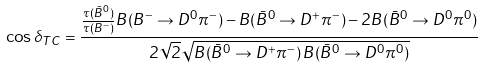Convert formula to latex. <formula><loc_0><loc_0><loc_500><loc_500>\cos \delta _ { T C } = \frac { \frac { \tau ( \bar { B } ^ { 0 } ) } { \tau ( B ^ { - } ) } B ( B ^ { - } \to D ^ { 0 } \pi ^ { - } ) - B ( \bar { B } ^ { 0 } \to D ^ { + } \pi ^ { - } ) - 2 B ( \bar { B } ^ { 0 } \to D ^ { 0 } \pi ^ { 0 } ) } { 2 \sqrt { 2 } \sqrt { B ( \bar { B } ^ { 0 } \to D ^ { + } \pi ^ { - } ) \, B ( \bar { B } ^ { 0 } \to D ^ { 0 } \pi ^ { 0 } ) } }</formula> 